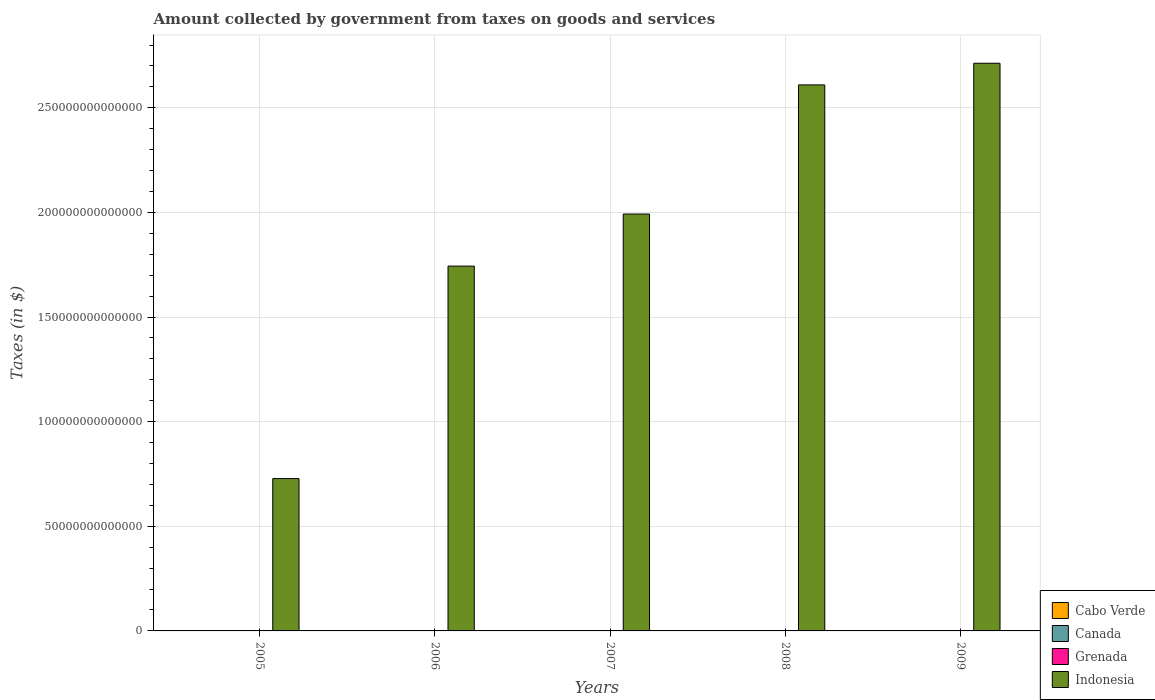How many bars are there on the 1st tick from the left?
Your answer should be compact. 4. How many bars are there on the 4th tick from the right?
Provide a succinct answer. 4. What is the amount collected by government from taxes on goods and services in Cabo Verde in 2005?
Keep it short and to the point. 1.25e+1. Across all years, what is the maximum amount collected by government from taxes on goods and services in Grenada?
Your response must be concise. 7.87e+07. Across all years, what is the minimum amount collected by government from taxes on goods and services in Cabo Verde?
Provide a short and direct response. 1.06e+1. In which year was the amount collected by government from taxes on goods and services in Cabo Verde maximum?
Ensure brevity in your answer.  2008. What is the total amount collected by government from taxes on goods and services in Canada in the graph?
Ensure brevity in your answer.  2.16e+11. What is the difference between the amount collected by government from taxes on goods and services in Indonesia in 2005 and that in 2008?
Make the answer very short. -1.88e+14. What is the difference between the amount collected by government from taxes on goods and services in Grenada in 2007 and the amount collected by government from taxes on goods and services in Canada in 2008?
Make the answer very short. -4.04e+1. What is the average amount collected by government from taxes on goods and services in Cabo Verde per year?
Your answer should be very brief. 1.24e+1. In the year 2006, what is the difference between the amount collected by government from taxes on goods and services in Grenada and amount collected by government from taxes on goods and services in Cabo Verde?
Give a very brief answer. -1.05e+1. In how many years, is the amount collected by government from taxes on goods and services in Canada greater than 230000000000000 $?
Keep it short and to the point. 0. What is the ratio of the amount collected by government from taxes on goods and services in Cabo Verde in 2006 to that in 2008?
Offer a terse response. 0.74. Is the amount collected by government from taxes on goods and services in Indonesia in 2008 less than that in 2009?
Offer a very short reply. Yes. What is the difference between the highest and the second highest amount collected by government from taxes on goods and services in Indonesia?
Make the answer very short. 1.03e+13. What is the difference between the highest and the lowest amount collected by government from taxes on goods and services in Canada?
Offer a terse response. 5.08e+09. In how many years, is the amount collected by government from taxes on goods and services in Indonesia greater than the average amount collected by government from taxes on goods and services in Indonesia taken over all years?
Your answer should be compact. 3. What does the 3rd bar from the left in 2005 represents?
Offer a terse response. Grenada. Are all the bars in the graph horizontal?
Your answer should be compact. No. How many years are there in the graph?
Provide a succinct answer. 5. What is the difference between two consecutive major ticks on the Y-axis?
Give a very brief answer. 5.00e+13. Does the graph contain grids?
Offer a very short reply. Yes. How are the legend labels stacked?
Offer a very short reply. Vertical. What is the title of the graph?
Provide a succinct answer. Amount collected by government from taxes on goods and services. What is the label or title of the X-axis?
Give a very brief answer. Years. What is the label or title of the Y-axis?
Your answer should be very brief. Taxes (in $). What is the Taxes (in $) in Cabo Verde in 2005?
Offer a terse response. 1.25e+1. What is the Taxes (in $) of Canada in 2005?
Your answer should be compact. 4.52e+1. What is the Taxes (in $) of Grenada in 2005?
Offer a terse response. 5.99e+07. What is the Taxes (in $) of Indonesia in 2005?
Provide a short and direct response. 7.28e+13. What is the Taxes (in $) in Cabo Verde in 2006?
Make the answer very short. 1.06e+1. What is the Taxes (in $) of Canada in 2006?
Your answer should be very brief. 4.48e+1. What is the Taxes (in $) in Grenada in 2006?
Offer a very short reply. 6.90e+07. What is the Taxes (in $) of Indonesia in 2006?
Your answer should be compact. 1.74e+14. What is the Taxes (in $) of Cabo Verde in 2007?
Offer a very short reply. 1.26e+1. What is the Taxes (in $) of Canada in 2007?
Your answer should be compact. 4.50e+1. What is the Taxes (in $) of Grenada in 2007?
Give a very brief answer. 7.13e+07. What is the Taxes (in $) of Indonesia in 2007?
Provide a short and direct response. 1.99e+14. What is the Taxes (in $) of Cabo Verde in 2008?
Give a very brief answer. 1.44e+1. What is the Taxes (in $) in Canada in 2008?
Ensure brevity in your answer.  4.05e+1. What is the Taxes (in $) of Grenada in 2008?
Provide a succinct answer. 7.87e+07. What is the Taxes (in $) in Indonesia in 2008?
Provide a succinct answer. 2.61e+14. What is the Taxes (in $) of Cabo Verde in 2009?
Provide a short and direct response. 1.19e+1. What is the Taxes (in $) in Canada in 2009?
Your response must be concise. 4.01e+1. What is the Taxes (in $) in Grenada in 2009?
Offer a very short reply. 7.60e+07. What is the Taxes (in $) in Indonesia in 2009?
Make the answer very short. 2.71e+14. Across all years, what is the maximum Taxes (in $) of Cabo Verde?
Give a very brief answer. 1.44e+1. Across all years, what is the maximum Taxes (in $) of Canada?
Offer a terse response. 4.52e+1. Across all years, what is the maximum Taxes (in $) of Grenada?
Offer a terse response. 7.87e+07. Across all years, what is the maximum Taxes (in $) of Indonesia?
Your response must be concise. 2.71e+14. Across all years, what is the minimum Taxes (in $) in Cabo Verde?
Provide a short and direct response. 1.06e+1. Across all years, what is the minimum Taxes (in $) of Canada?
Make the answer very short. 4.01e+1. Across all years, what is the minimum Taxes (in $) in Grenada?
Your answer should be compact. 5.99e+07. Across all years, what is the minimum Taxes (in $) in Indonesia?
Give a very brief answer. 7.28e+13. What is the total Taxes (in $) in Cabo Verde in the graph?
Your answer should be compact. 6.21e+1. What is the total Taxes (in $) in Canada in the graph?
Provide a short and direct response. 2.16e+11. What is the total Taxes (in $) in Grenada in the graph?
Offer a terse response. 3.55e+08. What is the total Taxes (in $) of Indonesia in the graph?
Offer a very short reply. 9.79e+14. What is the difference between the Taxes (in $) of Cabo Verde in 2005 and that in 2006?
Your answer should be very brief. 1.93e+09. What is the difference between the Taxes (in $) of Canada in 2005 and that in 2006?
Provide a succinct answer. 4.04e+08. What is the difference between the Taxes (in $) in Grenada in 2005 and that in 2006?
Offer a very short reply. -9.10e+06. What is the difference between the Taxes (in $) in Indonesia in 2005 and that in 2006?
Provide a short and direct response. -1.02e+14. What is the difference between the Taxes (in $) in Cabo Verde in 2005 and that in 2007?
Provide a succinct answer. -6.90e+07. What is the difference between the Taxes (in $) in Canada in 2005 and that in 2007?
Keep it short and to the point. 2.28e+08. What is the difference between the Taxes (in $) in Grenada in 2005 and that in 2007?
Keep it short and to the point. -1.14e+07. What is the difference between the Taxes (in $) of Indonesia in 2005 and that in 2007?
Offer a terse response. -1.26e+14. What is the difference between the Taxes (in $) of Cabo Verde in 2005 and that in 2008?
Give a very brief answer. -1.86e+09. What is the difference between the Taxes (in $) of Canada in 2005 and that in 2008?
Keep it short and to the point. 4.74e+09. What is the difference between the Taxes (in $) of Grenada in 2005 and that in 2008?
Offer a very short reply. -1.88e+07. What is the difference between the Taxes (in $) of Indonesia in 2005 and that in 2008?
Give a very brief answer. -1.88e+14. What is the difference between the Taxes (in $) of Cabo Verde in 2005 and that in 2009?
Keep it short and to the point. 6.39e+08. What is the difference between the Taxes (in $) in Canada in 2005 and that in 2009?
Provide a short and direct response. 5.08e+09. What is the difference between the Taxes (in $) in Grenada in 2005 and that in 2009?
Ensure brevity in your answer.  -1.61e+07. What is the difference between the Taxes (in $) of Indonesia in 2005 and that in 2009?
Offer a terse response. -1.98e+14. What is the difference between the Taxes (in $) of Cabo Verde in 2006 and that in 2007?
Offer a very short reply. -2.00e+09. What is the difference between the Taxes (in $) in Canada in 2006 and that in 2007?
Give a very brief answer. -1.76e+08. What is the difference between the Taxes (in $) of Grenada in 2006 and that in 2007?
Provide a succinct answer. -2.30e+06. What is the difference between the Taxes (in $) in Indonesia in 2006 and that in 2007?
Your answer should be compact. -2.49e+13. What is the difference between the Taxes (in $) of Cabo Verde in 2006 and that in 2008?
Offer a terse response. -3.79e+09. What is the difference between the Taxes (in $) in Canada in 2006 and that in 2008?
Ensure brevity in your answer.  4.34e+09. What is the difference between the Taxes (in $) in Grenada in 2006 and that in 2008?
Offer a very short reply. -9.70e+06. What is the difference between the Taxes (in $) in Indonesia in 2006 and that in 2008?
Keep it short and to the point. -8.66e+13. What is the difference between the Taxes (in $) in Cabo Verde in 2006 and that in 2009?
Offer a very short reply. -1.29e+09. What is the difference between the Taxes (in $) in Canada in 2006 and that in 2009?
Your answer should be very brief. 4.68e+09. What is the difference between the Taxes (in $) in Grenada in 2006 and that in 2009?
Your answer should be very brief. -7.00e+06. What is the difference between the Taxes (in $) of Indonesia in 2006 and that in 2009?
Make the answer very short. -9.69e+13. What is the difference between the Taxes (in $) in Cabo Verde in 2007 and that in 2008?
Provide a short and direct response. -1.79e+09. What is the difference between the Taxes (in $) in Canada in 2007 and that in 2008?
Give a very brief answer. 4.51e+09. What is the difference between the Taxes (in $) in Grenada in 2007 and that in 2008?
Your answer should be compact. -7.40e+06. What is the difference between the Taxes (in $) in Indonesia in 2007 and that in 2008?
Keep it short and to the point. -6.17e+13. What is the difference between the Taxes (in $) in Cabo Verde in 2007 and that in 2009?
Keep it short and to the point. 7.08e+08. What is the difference between the Taxes (in $) in Canada in 2007 and that in 2009?
Provide a succinct answer. 4.85e+09. What is the difference between the Taxes (in $) of Grenada in 2007 and that in 2009?
Your answer should be compact. -4.70e+06. What is the difference between the Taxes (in $) of Indonesia in 2007 and that in 2009?
Offer a terse response. -7.21e+13. What is the difference between the Taxes (in $) of Cabo Verde in 2008 and that in 2009?
Offer a very short reply. 2.50e+09. What is the difference between the Taxes (in $) in Canada in 2008 and that in 2009?
Your answer should be very brief. 3.42e+08. What is the difference between the Taxes (in $) in Grenada in 2008 and that in 2009?
Offer a terse response. 2.70e+06. What is the difference between the Taxes (in $) of Indonesia in 2008 and that in 2009?
Your answer should be very brief. -1.03e+13. What is the difference between the Taxes (in $) of Cabo Verde in 2005 and the Taxes (in $) of Canada in 2006?
Ensure brevity in your answer.  -3.23e+1. What is the difference between the Taxes (in $) of Cabo Verde in 2005 and the Taxes (in $) of Grenada in 2006?
Give a very brief answer. 1.25e+1. What is the difference between the Taxes (in $) in Cabo Verde in 2005 and the Taxes (in $) in Indonesia in 2006?
Keep it short and to the point. -1.74e+14. What is the difference between the Taxes (in $) of Canada in 2005 and the Taxes (in $) of Grenada in 2006?
Give a very brief answer. 4.51e+1. What is the difference between the Taxes (in $) of Canada in 2005 and the Taxes (in $) of Indonesia in 2006?
Your answer should be very brief. -1.74e+14. What is the difference between the Taxes (in $) in Grenada in 2005 and the Taxes (in $) in Indonesia in 2006?
Ensure brevity in your answer.  -1.74e+14. What is the difference between the Taxes (in $) in Cabo Verde in 2005 and the Taxes (in $) in Canada in 2007?
Your answer should be compact. -3.24e+1. What is the difference between the Taxes (in $) in Cabo Verde in 2005 and the Taxes (in $) in Grenada in 2007?
Offer a very short reply. 1.25e+1. What is the difference between the Taxes (in $) of Cabo Verde in 2005 and the Taxes (in $) of Indonesia in 2007?
Offer a very short reply. -1.99e+14. What is the difference between the Taxes (in $) in Canada in 2005 and the Taxes (in $) in Grenada in 2007?
Your answer should be compact. 4.51e+1. What is the difference between the Taxes (in $) in Canada in 2005 and the Taxes (in $) in Indonesia in 2007?
Offer a very short reply. -1.99e+14. What is the difference between the Taxes (in $) of Grenada in 2005 and the Taxes (in $) of Indonesia in 2007?
Your answer should be very brief. -1.99e+14. What is the difference between the Taxes (in $) of Cabo Verde in 2005 and the Taxes (in $) of Canada in 2008?
Ensure brevity in your answer.  -2.79e+1. What is the difference between the Taxes (in $) of Cabo Verde in 2005 and the Taxes (in $) of Grenada in 2008?
Ensure brevity in your answer.  1.25e+1. What is the difference between the Taxes (in $) in Cabo Verde in 2005 and the Taxes (in $) in Indonesia in 2008?
Provide a succinct answer. -2.61e+14. What is the difference between the Taxes (in $) of Canada in 2005 and the Taxes (in $) of Grenada in 2008?
Offer a very short reply. 4.51e+1. What is the difference between the Taxes (in $) in Canada in 2005 and the Taxes (in $) in Indonesia in 2008?
Make the answer very short. -2.61e+14. What is the difference between the Taxes (in $) in Grenada in 2005 and the Taxes (in $) in Indonesia in 2008?
Your response must be concise. -2.61e+14. What is the difference between the Taxes (in $) in Cabo Verde in 2005 and the Taxes (in $) in Canada in 2009?
Provide a short and direct response. -2.76e+1. What is the difference between the Taxes (in $) of Cabo Verde in 2005 and the Taxes (in $) of Grenada in 2009?
Provide a succinct answer. 1.25e+1. What is the difference between the Taxes (in $) in Cabo Verde in 2005 and the Taxes (in $) in Indonesia in 2009?
Offer a very short reply. -2.71e+14. What is the difference between the Taxes (in $) in Canada in 2005 and the Taxes (in $) in Grenada in 2009?
Offer a very short reply. 4.51e+1. What is the difference between the Taxes (in $) of Canada in 2005 and the Taxes (in $) of Indonesia in 2009?
Give a very brief answer. -2.71e+14. What is the difference between the Taxes (in $) in Grenada in 2005 and the Taxes (in $) in Indonesia in 2009?
Ensure brevity in your answer.  -2.71e+14. What is the difference between the Taxes (in $) in Cabo Verde in 2006 and the Taxes (in $) in Canada in 2007?
Keep it short and to the point. -3.44e+1. What is the difference between the Taxes (in $) in Cabo Verde in 2006 and the Taxes (in $) in Grenada in 2007?
Offer a terse response. 1.05e+1. What is the difference between the Taxes (in $) of Cabo Verde in 2006 and the Taxes (in $) of Indonesia in 2007?
Ensure brevity in your answer.  -1.99e+14. What is the difference between the Taxes (in $) of Canada in 2006 and the Taxes (in $) of Grenada in 2007?
Your answer should be very brief. 4.47e+1. What is the difference between the Taxes (in $) of Canada in 2006 and the Taxes (in $) of Indonesia in 2007?
Your answer should be compact. -1.99e+14. What is the difference between the Taxes (in $) of Grenada in 2006 and the Taxes (in $) of Indonesia in 2007?
Offer a terse response. -1.99e+14. What is the difference between the Taxes (in $) of Cabo Verde in 2006 and the Taxes (in $) of Canada in 2008?
Give a very brief answer. -2.99e+1. What is the difference between the Taxes (in $) in Cabo Verde in 2006 and the Taxes (in $) in Grenada in 2008?
Offer a terse response. 1.05e+1. What is the difference between the Taxes (in $) in Cabo Verde in 2006 and the Taxes (in $) in Indonesia in 2008?
Your answer should be very brief. -2.61e+14. What is the difference between the Taxes (in $) in Canada in 2006 and the Taxes (in $) in Grenada in 2008?
Give a very brief answer. 4.47e+1. What is the difference between the Taxes (in $) in Canada in 2006 and the Taxes (in $) in Indonesia in 2008?
Provide a succinct answer. -2.61e+14. What is the difference between the Taxes (in $) in Grenada in 2006 and the Taxes (in $) in Indonesia in 2008?
Provide a short and direct response. -2.61e+14. What is the difference between the Taxes (in $) of Cabo Verde in 2006 and the Taxes (in $) of Canada in 2009?
Your response must be concise. -2.95e+1. What is the difference between the Taxes (in $) in Cabo Verde in 2006 and the Taxes (in $) in Grenada in 2009?
Offer a very short reply. 1.05e+1. What is the difference between the Taxes (in $) in Cabo Verde in 2006 and the Taxes (in $) in Indonesia in 2009?
Provide a short and direct response. -2.71e+14. What is the difference between the Taxes (in $) in Canada in 2006 and the Taxes (in $) in Grenada in 2009?
Provide a short and direct response. 4.47e+1. What is the difference between the Taxes (in $) of Canada in 2006 and the Taxes (in $) of Indonesia in 2009?
Offer a terse response. -2.71e+14. What is the difference between the Taxes (in $) in Grenada in 2006 and the Taxes (in $) in Indonesia in 2009?
Provide a succinct answer. -2.71e+14. What is the difference between the Taxes (in $) of Cabo Verde in 2007 and the Taxes (in $) of Canada in 2008?
Provide a short and direct response. -2.79e+1. What is the difference between the Taxes (in $) of Cabo Verde in 2007 and the Taxes (in $) of Grenada in 2008?
Provide a short and direct response. 1.25e+1. What is the difference between the Taxes (in $) of Cabo Verde in 2007 and the Taxes (in $) of Indonesia in 2008?
Offer a very short reply. -2.61e+14. What is the difference between the Taxes (in $) of Canada in 2007 and the Taxes (in $) of Grenada in 2008?
Offer a terse response. 4.49e+1. What is the difference between the Taxes (in $) in Canada in 2007 and the Taxes (in $) in Indonesia in 2008?
Ensure brevity in your answer.  -2.61e+14. What is the difference between the Taxes (in $) in Grenada in 2007 and the Taxes (in $) in Indonesia in 2008?
Offer a very short reply. -2.61e+14. What is the difference between the Taxes (in $) of Cabo Verde in 2007 and the Taxes (in $) of Canada in 2009?
Ensure brevity in your answer.  -2.75e+1. What is the difference between the Taxes (in $) in Cabo Verde in 2007 and the Taxes (in $) in Grenada in 2009?
Offer a very short reply. 1.25e+1. What is the difference between the Taxes (in $) in Cabo Verde in 2007 and the Taxes (in $) in Indonesia in 2009?
Keep it short and to the point. -2.71e+14. What is the difference between the Taxes (in $) in Canada in 2007 and the Taxes (in $) in Grenada in 2009?
Provide a short and direct response. 4.49e+1. What is the difference between the Taxes (in $) of Canada in 2007 and the Taxes (in $) of Indonesia in 2009?
Your response must be concise. -2.71e+14. What is the difference between the Taxes (in $) of Grenada in 2007 and the Taxes (in $) of Indonesia in 2009?
Offer a terse response. -2.71e+14. What is the difference between the Taxes (in $) of Cabo Verde in 2008 and the Taxes (in $) of Canada in 2009?
Keep it short and to the point. -2.57e+1. What is the difference between the Taxes (in $) in Cabo Verde in 2008 and the Taxes (in $) in Grenada in 2009?
Make the answer very short. 1.43e+1. What is the difference between the Taxes (in $) in Cabo Verde in 2008 and the Taxes (in $) in Indonesia in 2009?
Provide a short and direct response. -2.71e+14. What is the difference between the Taxes (in $) in Canada in 2008 and the Taxes (in $) in Grenada in 2009?
Your response must be concise. 4.04e+1. What is the difference between the Taxes (in $) of Canada in 2008 and the Taxes (in $) of Indonesia in 2009?
Give a very brief answer. -2.71e+14. What is the difference between the Taxes (in $) of Grenada in 2008 and the Taxes (in $) of Indonesia in 2009?
Provide a succinct answer. -2.71e+14. What is the average Taxes (in $) in Cabo Verde per year?
Your answer should be very brief. 1.24e+1. What is the average Taxes (in $) of Canada per year?
Your answer should be very brief. 4.31e+1. What is the average Taxes (in $) in Grenada per year?
Keep it short and to the point. 7.10e+07. What is the average Taxes (in $) in Indonesia per year?
Provide a succinct answer. 1.96e+14. In the year 2005, what is the difference between the Taxes (in $) in Cabo Verde and Taxes (in $) in Canada?
Your answer should be very brief. -3.27e+1. In the year 2005, what is the difference between the Taxes (in $) in Cabo Verde and Taxes (in $) in Grenada?
Your answer should be compact. 1.25e+1. In the year 2005, what is the difference between the Taxes (in $) of Cabo Verde and Taxes (in $) of Indonesia?
Your answer should be compact. -7.28e+13. In the year 2005, what is the difference between the Taxes (in $) in Canada and Taxes (in $) in Grenada?
Give a very brief answer. 4.51e+1. In the year 2005, what is the difference between the Taxes (in $) of Canada and Taxes (in $) of Indonesia?
Give a very brief answer. -7.28e+13. In the year 2005, what is the difference between the Taxes (in $) of Grenada and Taxes (in $) of Indonesia?
Offer a very short reply. -7.28e+13. In the year 2006, what is the difference between the Taxes (in $) of Cabo Verde and Taxes (in $) of Canada?
Your answer should be compact. -3.42e+1. In the year 2006, what is the difference between the Taxes (in $) in Cabo Verde and Taxes (in $) in Grenada?
Give a very brief answer. 1.05e+1. In the year 2006, what is the difference between the Taxes (in $) in Cabo Verde and Taxes (in $) in Indonesia?
Provide a succinct answer. -1.74e+14. In the year 2006, what is the difference between the Taxes (in $) in Canada and Taxes (in $) in Grenada?
Offer a terse response. 4.47e+1. In the year 2006, what is the difference between the Taxes (in $) in Canada and Taxes (in $) in Indonesia?
Offer a terse response. -1.74e+14. In the year 2006, what is the difference between the Taxes (in $) of Grenada and Taxes (in $) of Indonesia?
Provide a short and direct response. -1.74e+14. In the year 2007, what is the difference between the Taxes (in $) in Cabo Verde and Taxes (in $) in Canada?
Ensure brevity in your answer.  -3.24e+1. In the year 2007, what is the difference between the Taxes (in $) of Cabo Verde and Taxes (in $) of Grenada?
Offer a terse response. 1.25e+1. In the year 2007, what is the difference between the Taxes (in $) in Cabo Verde and Taxes (in $) in Indonesia?
Ensure brevity in your answer.  -1.99e+14. In the year 2007, what is the difference between the Taxes (in $) in Canada and Taxes (in $) in Grenada?
Your answer should be compact. 4.49e+1. In the year 2007, what is the difference between the Taxes (in $) in Canada and Taxes (in $) in Indonesia?
Offer a terse response. -1.99e+14. In the year 2007, what is the difference between the Taxes (in $) of Grenada and Taxes (in $) of Indonesia?
Provide a short and direct response. -1.99e+14. In the year 2008, what is the difference between the Taxes (in $) in Cabo Verde and Taxes (in $) in Canada?
Give a very brief answer. -2.61e+1. In the year 2008, what is the difference between the Taxes (in $) of Cabo Verde and Taxes (in $) of Grenada?
Make the answer very short. 1.43e+1. In the year 2008, what is the difference between the Taxes (in $) in Cabo Verde and Taxes (in $) in Indonesia?
Your answer should be very brief. -2.61e+14. In the year 2008, what is the difference between the Taxes (in $) of Canada and Taxes (in $) of Grenada?
Make the answer very short. 4.04e+1. In the year 2008, what is the difference between the Taxes (in $) in Canada and Taxes (in $) in Indonesia?
Keep it short and to the point. -2.61e+14. In the year 2008, what is the difference between the Taxes (in $) of Grenada and Taxes (in $) of Indonesia?
Offer a very short reply. -2.61e+14. In the year 2009, what is the difference between the Taxes (in $) of Cabo Verde and Taxes (in $) of Canada?
Ensure brevity in your answer.  -2.82e+1. In the year 2009, what is the difference between the Taxes (in $) of Cabo Verde and Taxes (in $) of Grenada?
Ensure brevity in your answer.  1.18e+1. In the year 2009, what is the difference between the Taxes (in $) of Cabo Verde and Taxes (in $) of Indonesia?
Your answer should be compact. -2.71e+14. In the year 2009, what is the difference between the Taxes (in $) in Canada and Taxes (in $) in Grenada?
Make the answer very short. 4.00e+1. In the year 2009, what is the difference between the Taxes (in $) of Canada and Taxes (in $) of Indonesia?
Provide a short and direct response. -2.71e+14. In the year 2009, what is the difference between the Taxes (in $) of Grenada and Taxes (in $) of Indonesia?
Offer a terse response. -2.71e+14. What is the ratio of the Taxes (in $) in Cabo Verde in 2005 to that in 2006?
Provide a short and direct response. 1.18. What is the ratio of the Taxes (in $) of Grenada in 2005 to that in 2006?
Your response must be concise. 0.87. What is the ratio of the Taxes (in $) of Indonesia in 2005 to that in 2006?
Provide a succinct answer. 0.42. What is the ratio of the Taxes (in $) in Cabo Verde in 2005 to that in 2007?
Your answer should be compact. 0.99. What is the ratio of the Taxes (in $) in Grenada in 2005 to that in 2007?
Ensure brevity in your answer.  0.84. What is the ratio of the Taxes (in $) of Indonesia in 2005 to that in 2007?
Give a very brief answer. 0.37. What is the ratio of the Taxes (in $) in Cabo Verde in 2005 to that in 2008?
Offer a terse response. 0.87. What is the ratio of the Taxes (in $) of Canada in 2005 to that in 2008?
Provide a short and direct response. 1.12. What is the ratio of the Taxes (in $) in Grenada in 2005 to that in 2008?
Offer a very short reply. 0.76. What is the ratio of the Taxes (in $) of Indonesia in 2005 to that in 2008?
Offer a terse response. 0.28. What is the ratio of the Taxes (in $) in Cabo Verde in 2005 to that in 2009?
Offer a very short reply. 1.05. What is the ratio of the Taxes (in $) in Canada in 2005 to that in 2009?
Offer a very short reply. 1.13. What is the ratio of the Taxes (in $) in Grenada in 2005 to that in 2009?
Ensure brevity in your answer.  0.79. What is the ratio of the Taxes (in $) of Indonesia in 2005 to that in 2009?
Your answer should be very brief. 0.27. What is the ratio of the Taxes (in $) in Cabo Verde in 2006 to that in 2007?
Provide a succinct answer. 0.84. What is the ratio of the Taxes (in $) of Indonesia in 2006 to that in 2007?
Your response must be concise. 0.88. What is the ratio of the Taxes (in $) in Cabo Verde in 2006 to that in 2008?
Your answer should be compact. 0.74. What is the ratio of the Taxes (in $) of Canada in 2006 to that in 2008?
Offer a very short reply. 1.11. What is the ratio of the Taxes (in $) in Grenada in 2006 to that in 2008?
Give a very brief answer. 0.88. What is the ratio of the Taxes (in $) in Indonesia in 2006 to that in 2008?
Your answer should be very brief. 0.67. What is the ratio of the Taxes (in $) of Cabo Verde in 2006 to that in 2009?
Keep it short and to the point. 0.89. What is the ratio of the Taxes (in $) in Canada in 2006 to that in 2009?
Give a very brief answer. 1.12. What is the ratio of the Taxes (in $) in Grenada in 2006 to that in 2009?
Keep it short and to the point. 0.91. What is the ratio of the Taxes (in $) of Indonesia in 2006 to that in 2009?
Your response must be concise. 0.64. What is the ratio of the Taxes (in $) of Cabo Verde in 2007 to that in 2008?
Give a very brief answer. 0.88. What is the ratio of the Taxes (in $) of Canada in 2007 to that in 2008?
Give a very brief answer. 1.11. What is the ratio of the Taxes (in $) of Grenada in 2007 to that in 2008?
Keep it short and to the point. 0.91. What is the ratio of the Taxes (in $) in Indonesia in 2007 to that in 2008?
Your answer should be compact. 0.76. What is the ratio of the Taxes (in $) in Cabo Verde in 2007 to that in 2009?
Keep it short and to the point. 1.06. What is the ratio of the Taxes (in $) in Canada in 2007 to that in 2009?
Offer a terse response. 1.12. What is the ratio of the Taxes (in $) in Grenada in 2007 to that in 2009?
Keep it short and to the point. 0.94. What is the ratio of the Taxes (in $) in Indonesia in 2007 to that in 2009?
Provide a succinct answer. 0.73. What is the ratio of the Taxes (in $) in Cabo Verde in 2008 to that in 2009?
Give a very brief answer. 1.21. What is the ratio of the Taxes (in $) in Canada in 2008 to that in 2009?
Your answer should be compact. 1.01. What is the ratio of the Taxes (in $) of Grenada in 2008 to that in 2009?
Your answer should be compact. 1.04. What is the ratio of the Taxes (in $) in Indonesia in 2008 to that in 2009?
Offer a terse response. 0.96. What is the difference between the highest and the second highest Taxes (in $) of Cabo Verde?
Make the answer very short. 1.79e+09. What is the difference between the highest and the second highest Taxes (in $) of Canada?
Ensure brevity in your answer.  2.28e+08. What is the difference between the highest and the second highest Taxes (in $) of Grenada?
Your answer should be compact. 2.70e+06. What is the difference between the highest and the second highest Taxes (in $) of Indonesia?
Keep it short and to the point. 1.03e+13. What is the difference between the highest and the lowest Taxes (in $) in Cabo Verde?
Provide a short and direct response. 3.79e+09. What is the difference between the highest and the lowest Taxes (in $) of Canada?
Provide a short and direct response. 5.08e+09. What is the difference between the highest and the lowest Taxes (in $) of Grenada?
Give a very brief answer. 1.88e+07. What is the difference between the highest and the lowest Taxes (in $) in Indonesia?
Provide a short and direct response. 1.98e+14. 